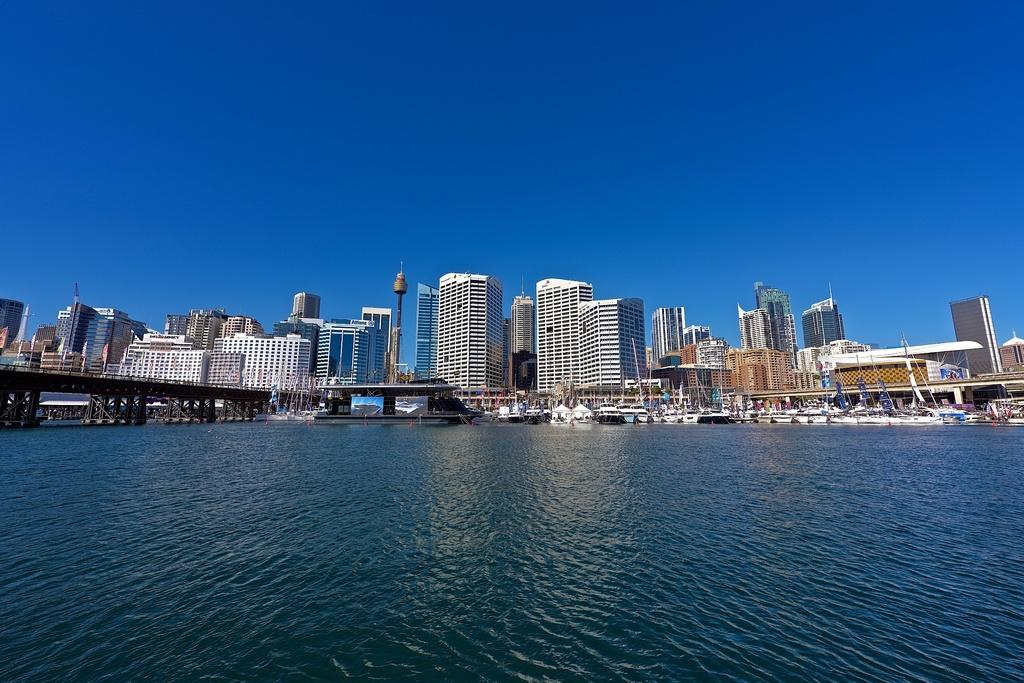What is the main feature of the image? The main feature of the image is water. What structure can be seen crossing over the water? There is a bridge in the image. What type of vehicles are on the water? There are boats on the surface of the water. What color are the boats? The boats are white in color. What can be seen in the distance behind the water and boats? There are buildings and the sky visible in the background of the image. How many ladybugs are crawling on the bridge in the image? There are no ladybugs present in the image; the focus is on the water, bridge, boats, and background. 